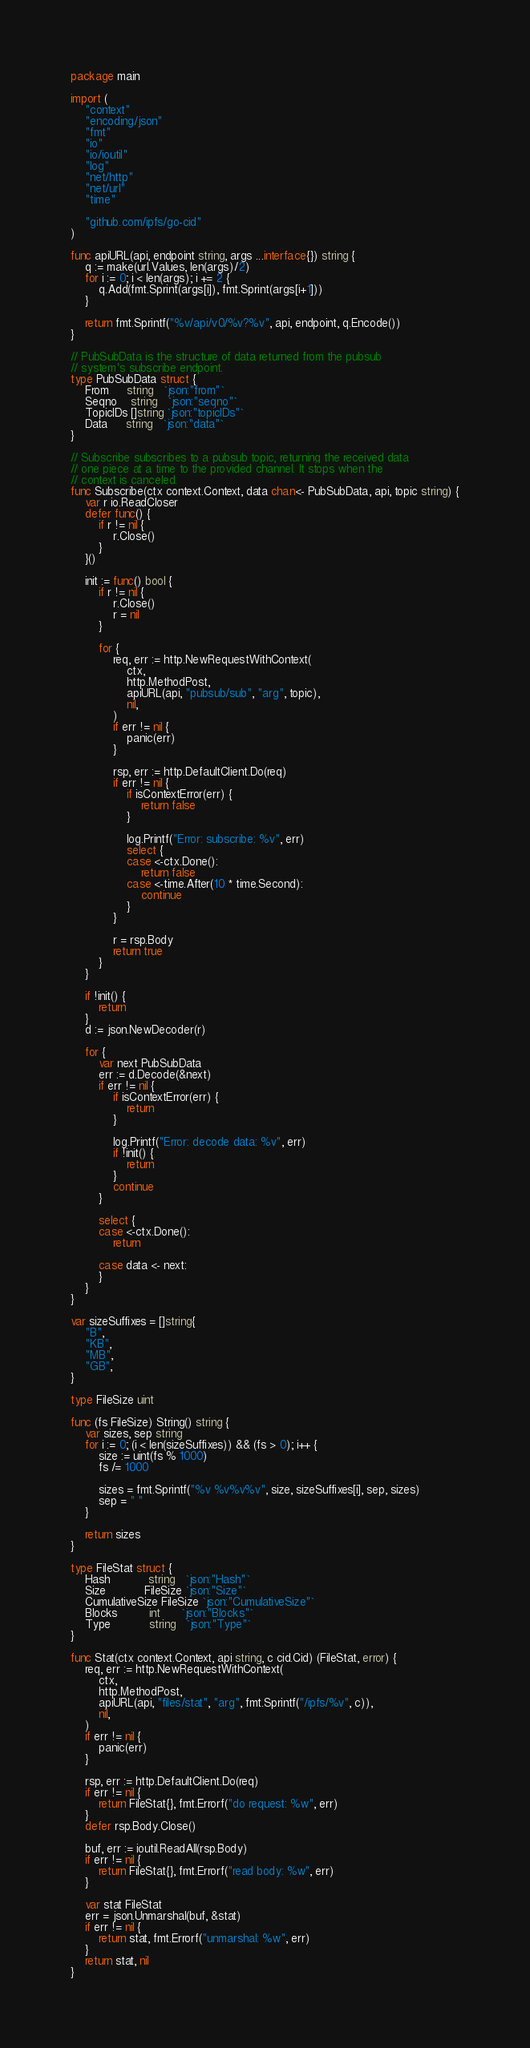<code> <loc_0><loc_0><loc_500><loc_500><_Go_>package main

import (
	"context"
	"encoding/json"
	"fmt"
	"io"
	"io/ioutil"
	"log"
	"net/http"
	"net/url"
	"time"

	"github.com/ipfs/go-cid"
)

func apiURL(api, endpoint string, args ...interface{}) string {
	q := make(url.Values, len(args)/2)
	for i := 0; i < len(args); i += 2 {
		q.Add(fmt.Sprint(args[i]), fmt.Sprint(args[i+1]))
	}

	return fmt.Sprintf("%v/api/v0/%v?%v", api, endpoint, q.Encode())
}

// PubSubData is the structure of data returned from the pubsub
// system's subscribe endpoint.
type PubSubData struct {
	From     string   `json:"from"`
	Seqno    string   `json:"seqno"`
	TopicIDs []string `json:"topicIDs"`
	Data     string   `json:"data"`
}

// Subscribe subscribes to a pubsub topic, returning the received data
// one piece at a time to the provided channel. It stops when the
// context is canceled.
func Subscribe(ctx context.Context, data chan<- PubSubData, api, topic string) {
	var r io.ReadCloser
	defer func() {
		if r != nil {
			r.Close()
		}
	}()

	init := func() bool {
		if r != nil {
			r.Close()
			r = nil
		}

		for {
			req, err := http.NewRequestWithContext(
				ctx,
				http.MethodPost,
				apiURL(api, "pubsub/sub", "arg", topic),
				nil,
			)
			if err != nil {
				panic(err)
			}

			rsp, err := http.DefaultClient.Do(req)
			if err != nil {
				if isContextError(err) {
					return false
				}

				log.Printf("Error: subscribe: %v", err)
				select {
				case <-ctx.Done():
					return false
				case <-time.After(10 * time.Second):
					continue
				}
			}

			r = rsp.Body
			return true
		}
	}

	if !init() {
		return
	}
	d := json.NewDecoder(r)

	for {
		var next PubSubData
		err := d.Decode(&next)
		if err != nil {
			if isContextError(err) {
				return
			}

			log.Printf("Error: decode data: %v", err)
			if !init() {
				return
			}
			continue
		}

		select {
		case <-ctx.Done():
			return

		case data <- next:
		}
	}
}

var sizeSuffixes = []string{
	"B",
	"KB",
	"MB",
	"GB",
}

type FileSize uint

func (fs FileSize) String() string {
	var sizes, sep string
	for i := 0; (i < len(sizeSuffixes)) && (fs > 0); i++ {
		size := uint(fs % 1000)
		fs /= 1000

		sizes = fmt.Sprintf("%v %v%v%v", size, sizeSuffixes[i], sep, sizes)
		sep = " "
	}

	return sizes
}

type FileStat struct {
	Hash           string   `json:"Hash"`
	Size           FileSize `json:"Size"`
	CumulativeSize FileSize `json:"CumulativeSize"`
	Blocks         int      `json:"Blocks"`
	Type           string   `json:"Type"`
}

func Stat(ctx context.Context, api string, c cid.Cid) (FileStat, error) {
	req, err := http.NewRequestWithContext(
		ctx,
		http.MethodPost,
		apiURL(api, "files/stat", "arg", fmt.Sprintf("/ipfs/%v", c)),
		nil,
	)
	if err != nil {
		panic(err)
	}

	rsp, err := http.DefaultClient.Do(req)
	if err != nil {
		return FileStat{}, fmt.Errorf("do request: %w", err)
	}
	defer rsp.Body.Close()

	buf, err := ioutil.ReadAll(rsp.Body)
	if err != nil {
		return FileStat{}, fmt.Errorf("read body: %w", err)
	}

	var stat FileStat
	err = json.Unmarshal(buf, &stat)
	if err != nil {
		return stat, fmt.Errorf("unmarshal: %w", err)
	}
	return stat, nil
}
</code> 